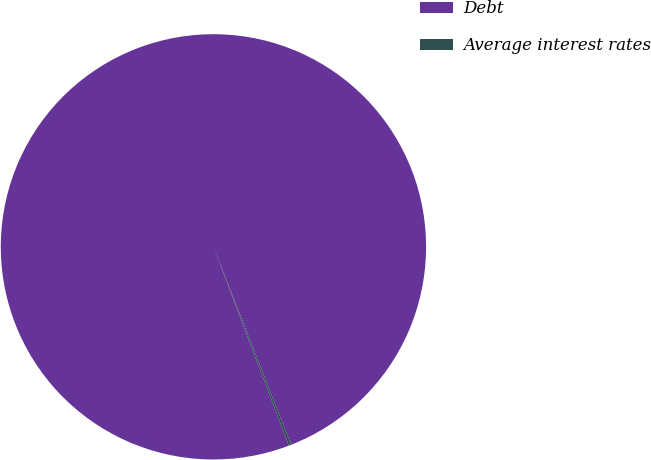Convert chart to OTSL. <chart><loc_0><loc_0><loc_500><loc_500><pie_chart><fcel>Debt<fcel>Average interest rates<nl><fcel>99.82%<fcel>0.18%<nl></chart> 